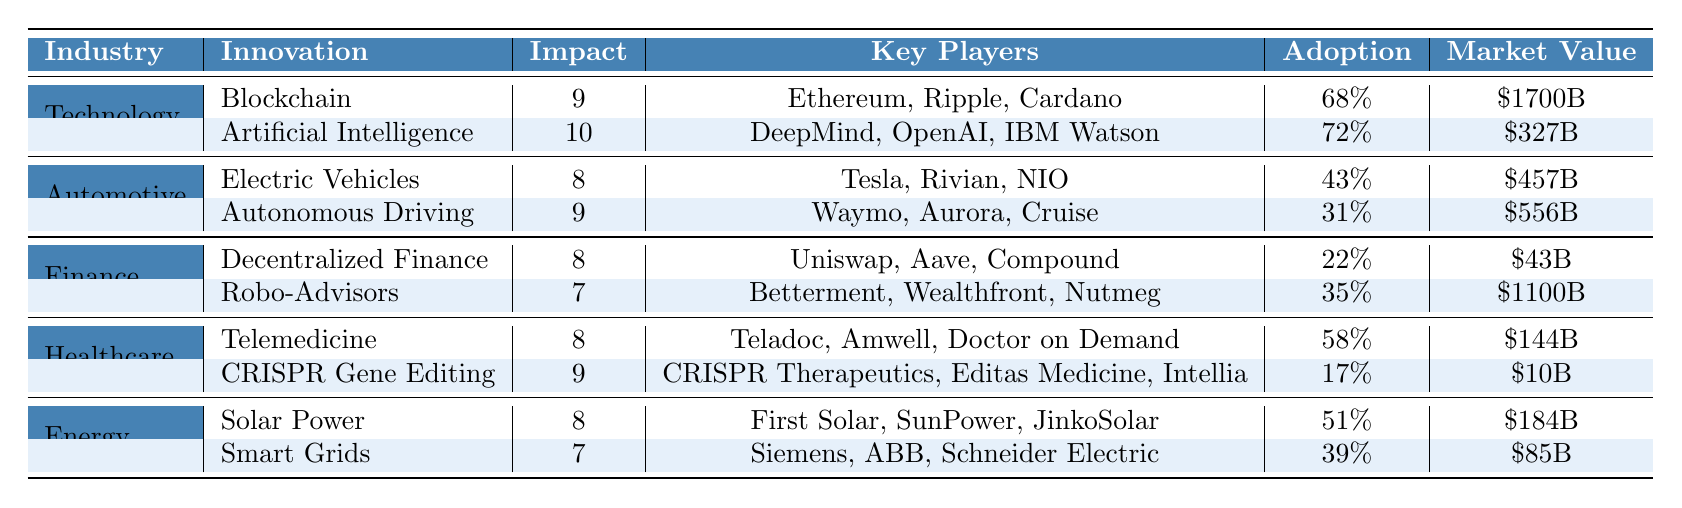What is the highest impact innovation in the Technology industry? The highest impact innovation in the Technology industry is Artificial Intelligence, which has an impact level of 10.
Answer: Artificial Intelligence Which industry has the lowest adoption rate for disruptive innovations? The Finance industry has the lowest adoption rate for its disruptive innovations at 22% for Decentralized Finance.
Answer: Finance What is the total market value of the disruptive innovations in the Automotive industry? The market values for the disruptive innovations in the Automotive industry are $457B for Electric Vehicles and $556B for Autonomous Driving. Summing these gives $457B + $556B = $1013B.
Answer: $1013B Is the adoption rate for CRISPR Gene Editing higher than that for Telemedicine? The adoption rate for CRISPR Gene Editing is 17%, while Telemedicine has an adoption rate of 58%. Since 17% is less than 58%, the statement is false.
Answer: No Which key player is associated with the highest impact innovation across all industries? The highest impact innovation is Artificial Intelligence in the Technology industry, with key players including DeepMind, OpenAI, and IBM Watson.
Answer: Artificial Intelligence What is the average impact level of innovations in the Energy industry? The impact levels in the Energy industry are 8 for Solar Power and 7 for Smart Grids. To find the average, we sum these values: 8 + 7 = 15, then divide by 2, which gives 15/2 = 7.5.
Answer: 7.5 Can we say that the market value of Robo-Advisors is greater than that of Decentralized Finance? The market value of Robo-Advisors is $1100B, while Decentralized Finance has a market value of $43B. Since $1100B is greater than $43B, the statement is true.
Answer: Yes What percentage of the market value does Electric Vehicles represent compared to the total market values across all industries? The total market value for all innovations sums to $1700B + $327B + $457B + $556B + $43B + $1100B + $144B + $10B + $184B + $85B = $3560B. Electric Vehicles has a market value of $457B, which is (457/3560) * 100% = 12.84%.
Answer: 12.84% Which industry has the highest adoption rate for its innovative solutions? In the Technology industry, Artificial Intelligence has an adoption rate of 72%, which is the highest among all industries.
Answer: Technology What is the difference in market value between Smart Grids and CRISPR Gene Editing? The market value of Smart Grids is $85B and that of CRISPR Gene Editing is $10B. The difference is $85B - $10B = $75B.
Answer: $75B 